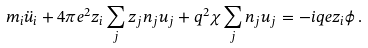Convert formula to latex. <formula><loc_0><loc_0><loc_500><loc_500>m _ { i } \ddot { u } _ { i } + 4 \pi e ^ { 2 } z _ { i } \sum _ { j } z _ { j } n _ { j } u _ { j } + q ^ { 2 } \chi \sum _ { j } n _ { j } u _ { j } = - i q e z _ { i } \phi \, .</formula> 